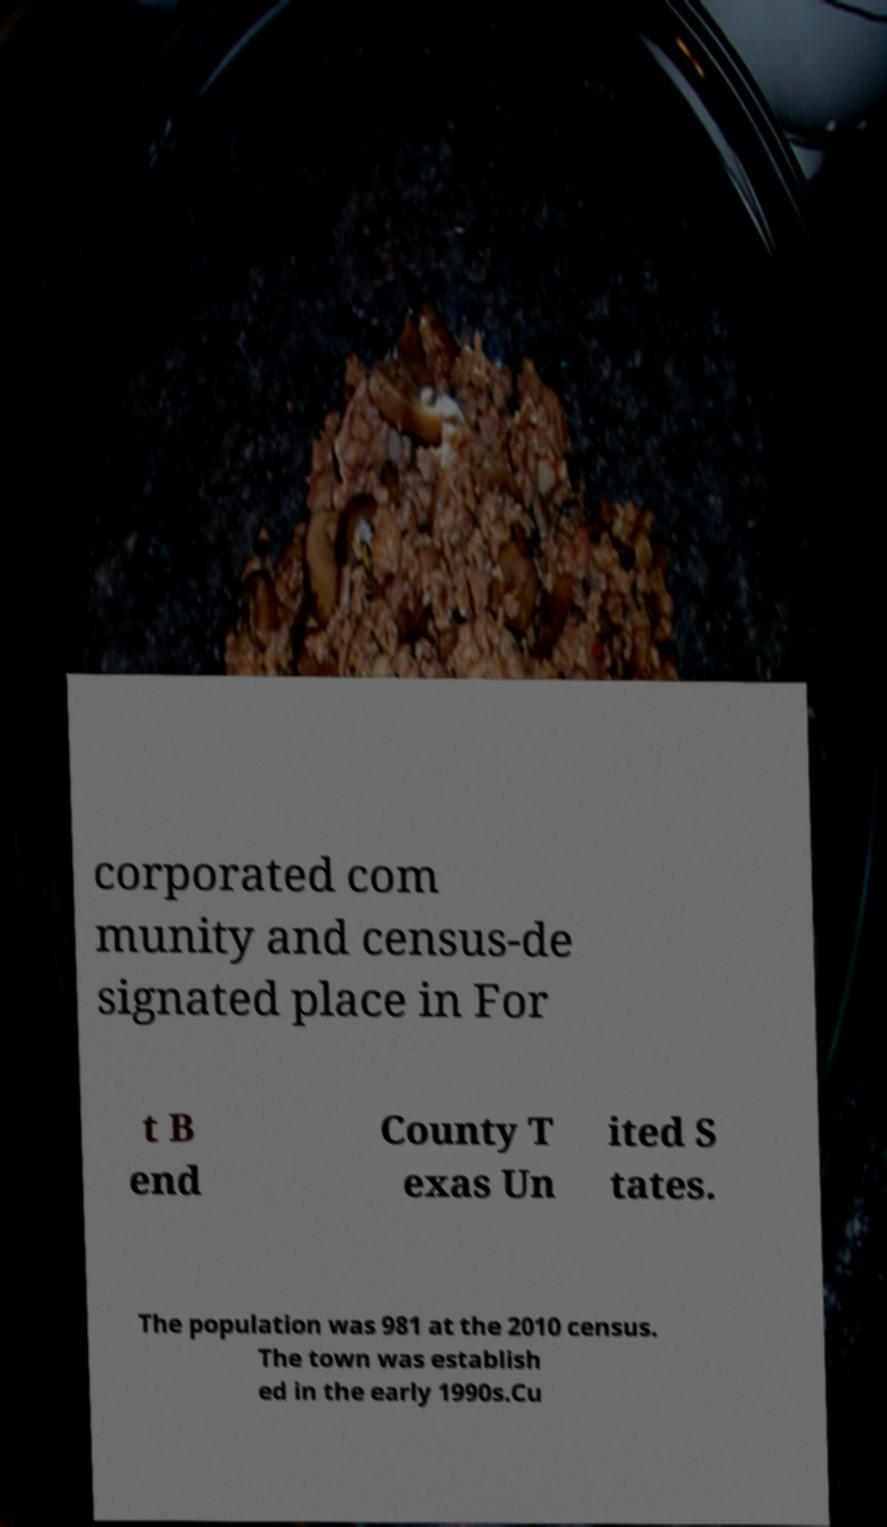There's text embedded in this image that I need extracted. Can you transcribe it verbatim? corporated com munity and census-de signated place in For t B end County T exas Un ited S tates. The population was 981 at the 2010 census. The town was establish ed in the early 1990s.Cu 